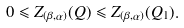<formula> <loc_0><loc_0><loc_500><loc_500>0 \leqslant Z _ { ( \beta , \alpha ) } ( Q ) \leqslant Z _ { ( \beta , \alpha ) } ( Q _ { 1 } ) .</formula> 